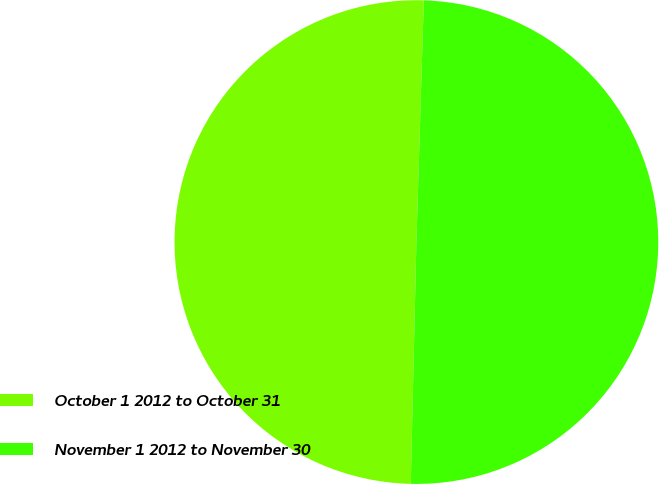<chart> <loc_0><loc_0><loc_500><loc_500><pie_chart><fcel>October 1 2012 to October 31<fcel>November 1 2012 to November 30<nl><fcel>50.12%<fcel>49.88%<nl></chart> 